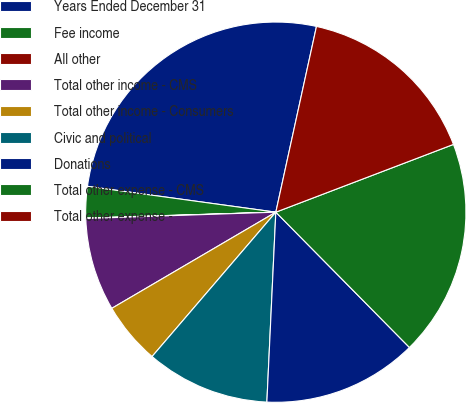<chart> <loc_0><loc_0><loc_500><loc_500><pie_chart><fcel>Years Ended December 31<fcel>Fee income<fcel>All other<fcel>Total other income - CMS<fcel>Total other income - Consumers<fcel>Civic and political<fcel>Donations<fcel>Total other expense - CMS<fcel>Total other expense -<nl><fcel>26.26%<fcel>2.66%<fcel>0.04%<fcel>7.91%<fcel>5.28%<fcel>10.53%<fcel>13.15%<fcel>18.4%<fcel>15.77%<nl></chart> 